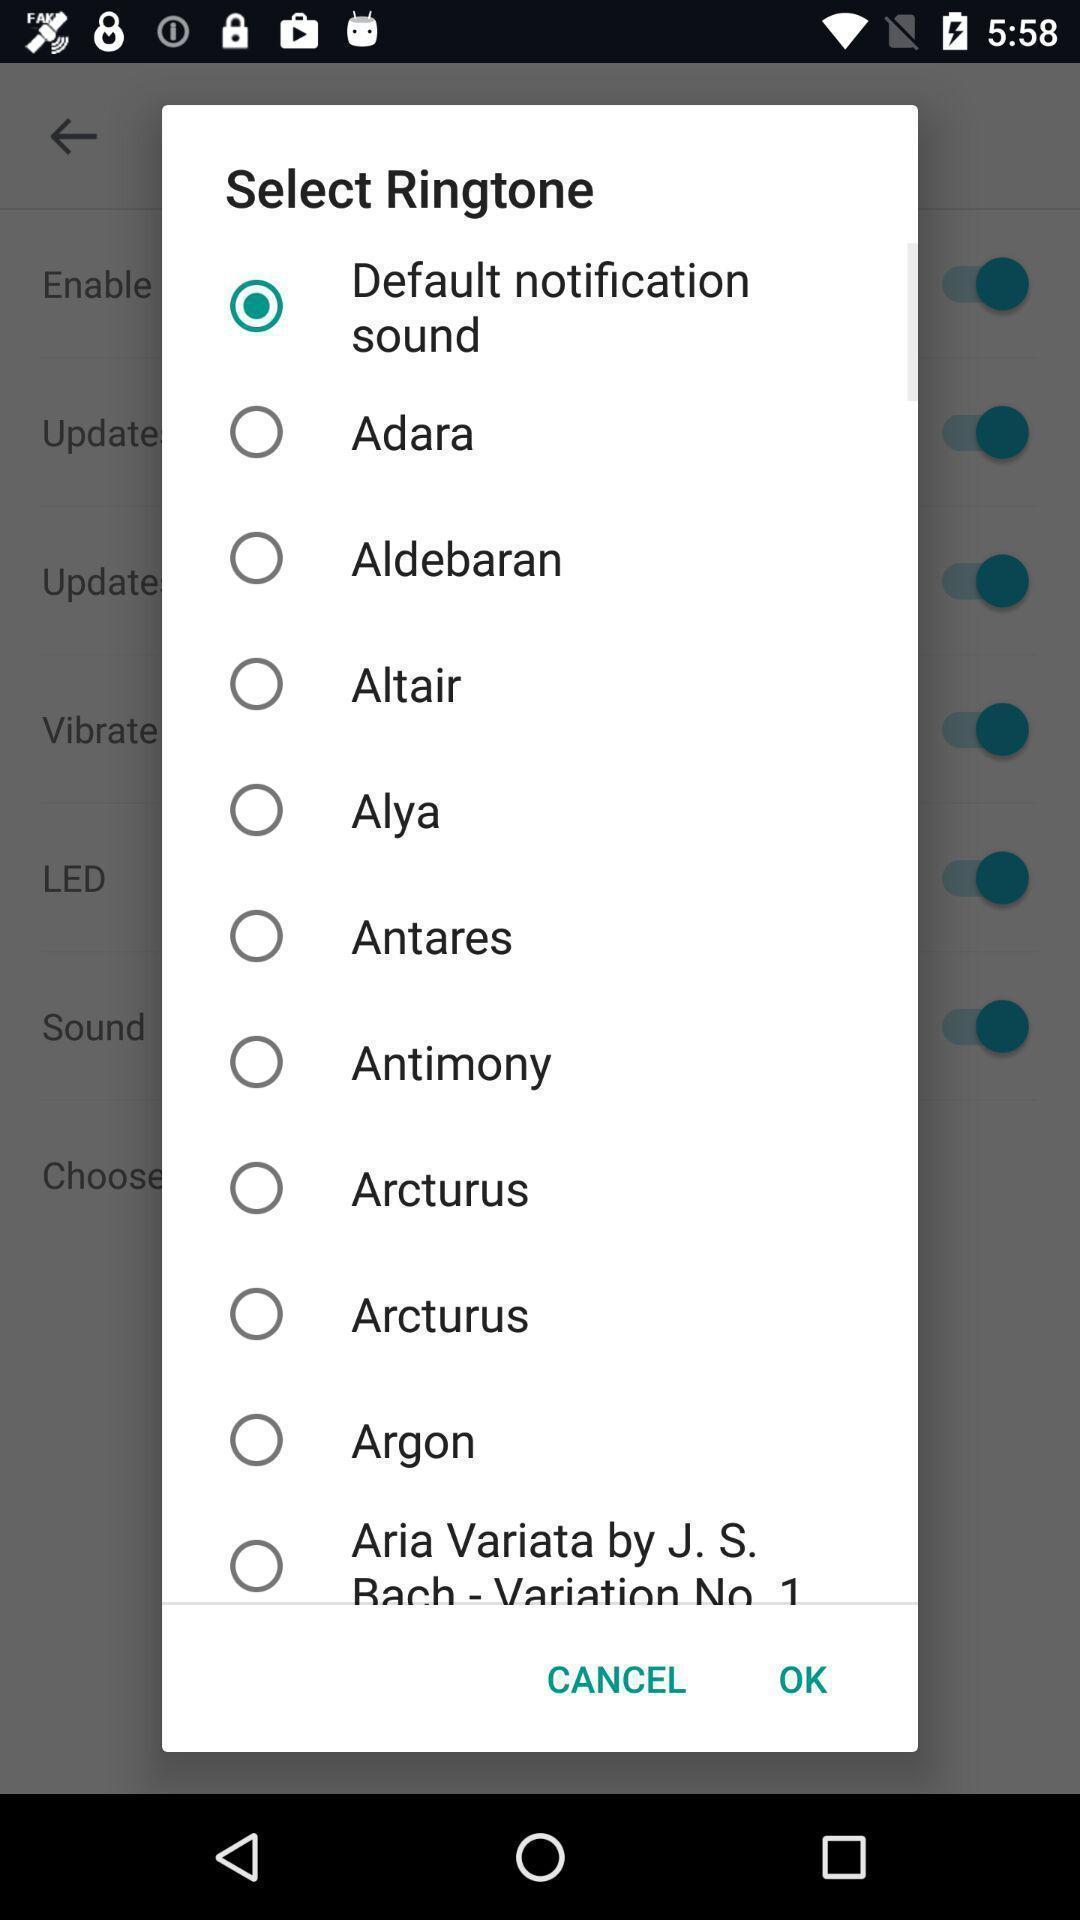What can you discern from this picture? Pop-up displaying the list of ringtones to select. 